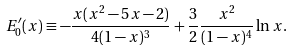<formula> <loc_0><loc_0><loc_500><loc_500>E _ { 0 } ^ { \prime } ( x ) \equiv - \frac { x ( x ^ { 2 } - 5 x - 2 ) } { 4 ( 1 - x ) ^ { 3 } } + \frac { 3 } { 2 } \frac { x ^ { 2 } } { ( 1 - x ) ^ { 4 } } \ln x .</formula> 